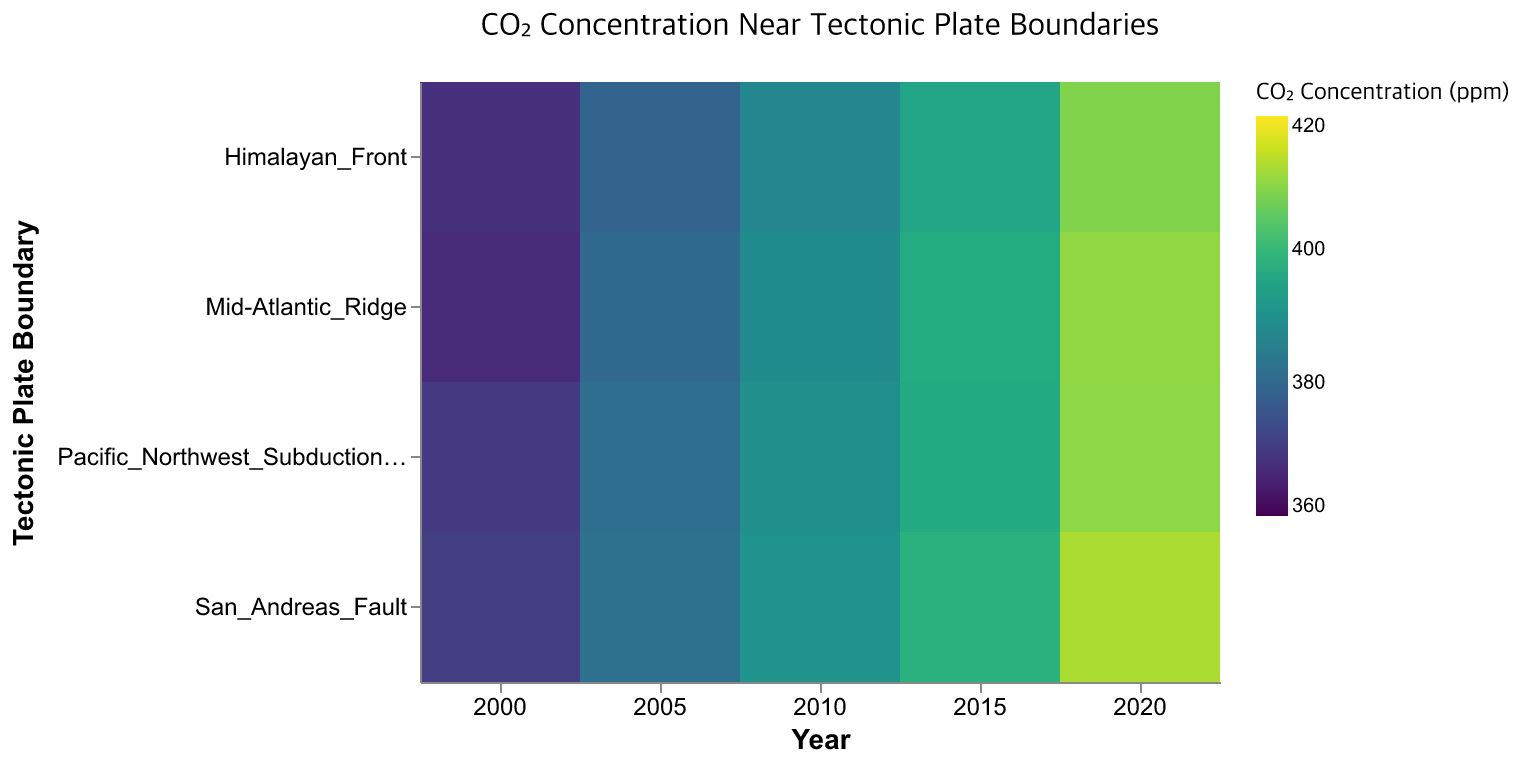What's the title of the heatmap? The title is displayed at the top center of the heatmap in a larger font size. It reads "CO₂ Concentration Near Tectonic Plate Boundaries".
Answer: CO₂ Concentration Near Tectonic Plate Boundaries Which tectonic plate boundary shows the highest CO2 concentration in 2020? Look at the column for 2020 and find the cell with the darkest color representing the highest CO2 concentration. The darkest cell in the 2020 column is for the San Andreas Fault.
Answer: San Andreas Fault How did the CO2 concentration change for the Mid-Atlantic Ridge between 2000 and 2020? Compare the color in the 2000 row and the 2020 row for the Mid-Atlantic Ridge. The concentration increases from a lighter shade to a darker shade of green. Quantitatively, it increased from 367.2 ppm in 2000 to 410.2 ppm in 2020.
Answer: Increased by 43 ppm Which plate boundary shows the smallest increase in CO2 concentration from 2015 to 2020? Compare the color differences between 2015 and 2020 for all plate boundaries. The smallest increase corresponds to the plate boundary with the least color change. The Pacific Northwest Subduction Zone shows a color change from 396.4 ppm to 409.9 ppm, the least increase among the boundaries.
Answer: Pacific Northwest Subduction Zone Are the changes in CO2 concentration uniform across all tectonic plate boundaries? Observe the differences in color changes for each boundary over the years. Different boundaries exhibit different rates of change, indicating the changes are not uniform, with the San Andreas Fault showing the highest increases.
Answer: No What is the average CO2 concentration in 2015 across all plate boundaries? Add the CO2 concentrations for all plate boundaries in 2015 and divide by the number of boundaries: (398.2 + 396.8 + 396.4 + 395.2) / 4 = 396.65 ppm.
Answer: 396.65 ppm Which boundary shows the largest variation in CO2 over the years? Identify the boundary with the widest range of CO2 concentrations from the lightest to the darkest shade. The San Andreas Fault shows considerable variation from 370.5 ppm in 2000 to 412.5 ppm in 2020.
Answer: San Andreas Fault From 2005 to 2015, which plate boundary had the largest relative increase in CO2 concentration? Calculate the percentage increase for all boundaries between these years using the formula ((CO2_2015 - CO2_2005) / CO2_2005) * 100%. The largest relative increase is seen for the San Andreas Fault: ((398.2 - 382.3) / 382.3) * 100% ≈ 4.17%.
Answer: San Andreas Fault What color scheme is used to represent CO2 concentration values in the heatmap? The legend shows that a viridis color scheme is used, ranging from a lighter green to a darker green. The scale is used to represent variations in CO2 concentration levels.
Answer: Viridis 